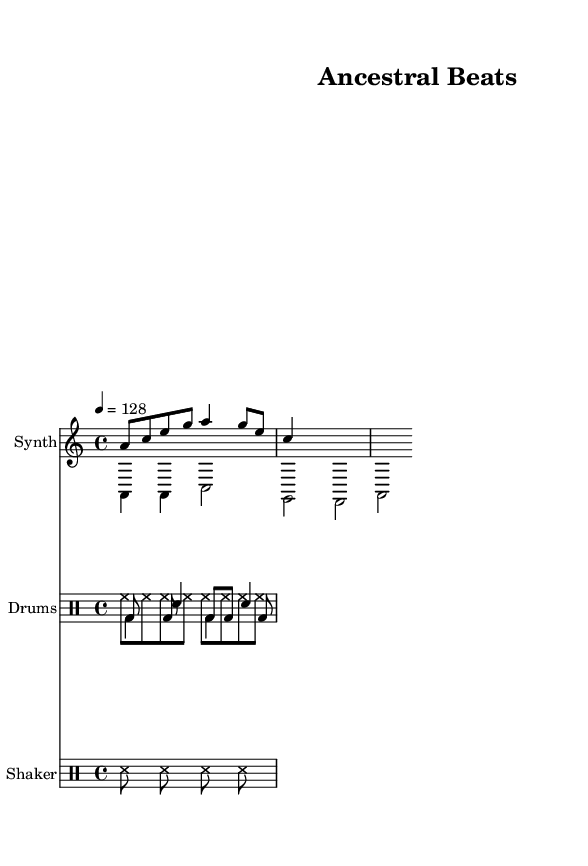What is the key signature of this music? The key signature is A minor, which has no sharps or flats and is indicated at the beginning of the piece.
Answer: A minor What is the time signature used in this music? The time signature is 4/4, which is shown at the beginning of the score and indicates four beats per measure.
Answer: 4/4 What is the tempo marking for this piece? The tempo marking is 128 beats per minute, indicated by the notation "4 = 128" at the beginning of the score.
Answer: 128 How many different drum voices are used in this piece? There are four distinct drum voices shown in two separate DrumStaffs: native drum, kick drum, snare drum, and hi-hat, plus an additional staff for the shaker.
Answer: Four What is the rhythmic pattern of the native drum? The rhythmic pattern of the native drum consists of a series of bass drum (bd) beats and rests, represented as "bd8 s bd s bd bd s bd" in the drummode notation.
Answer: bd8 s bd s bd bd s bd Which voice holds the melody in the synth section? The melody in the synth section is specified as "voiceOne," which corresponds to the musical line containing the notes that create the primary melodic line.
Answer: voiceOne 